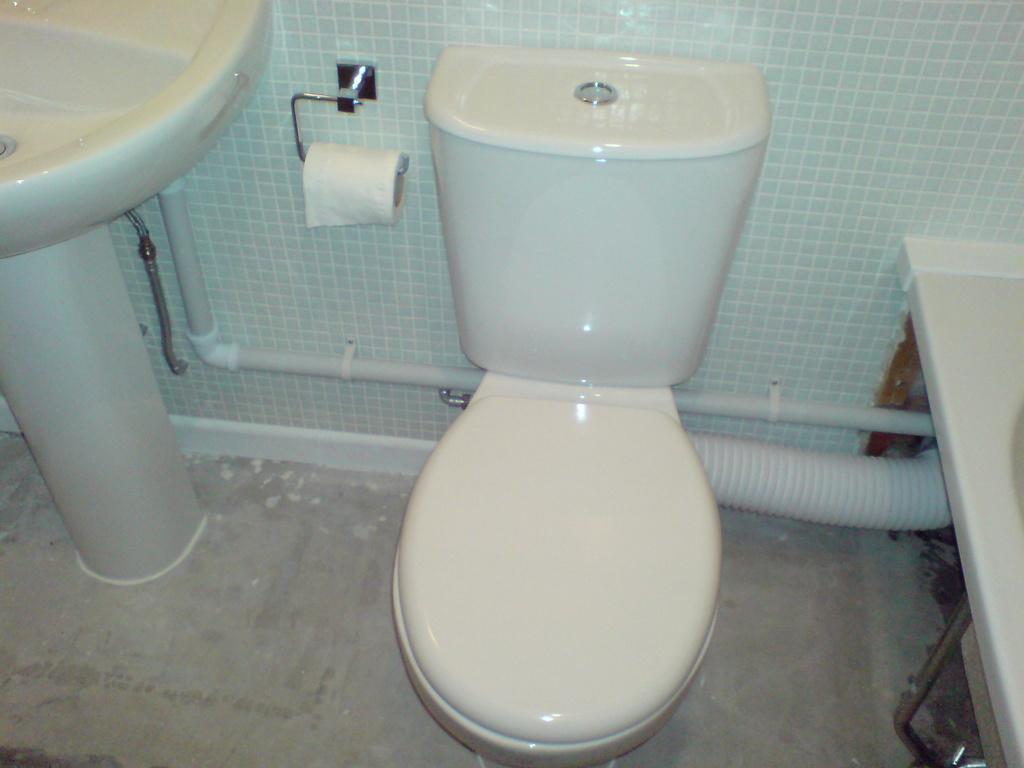Could you give a brief overview of what you see in this image? In this picture I can see the washbasin, few pipes, a toilet paper and the western toilet and I can see the marble wall. 